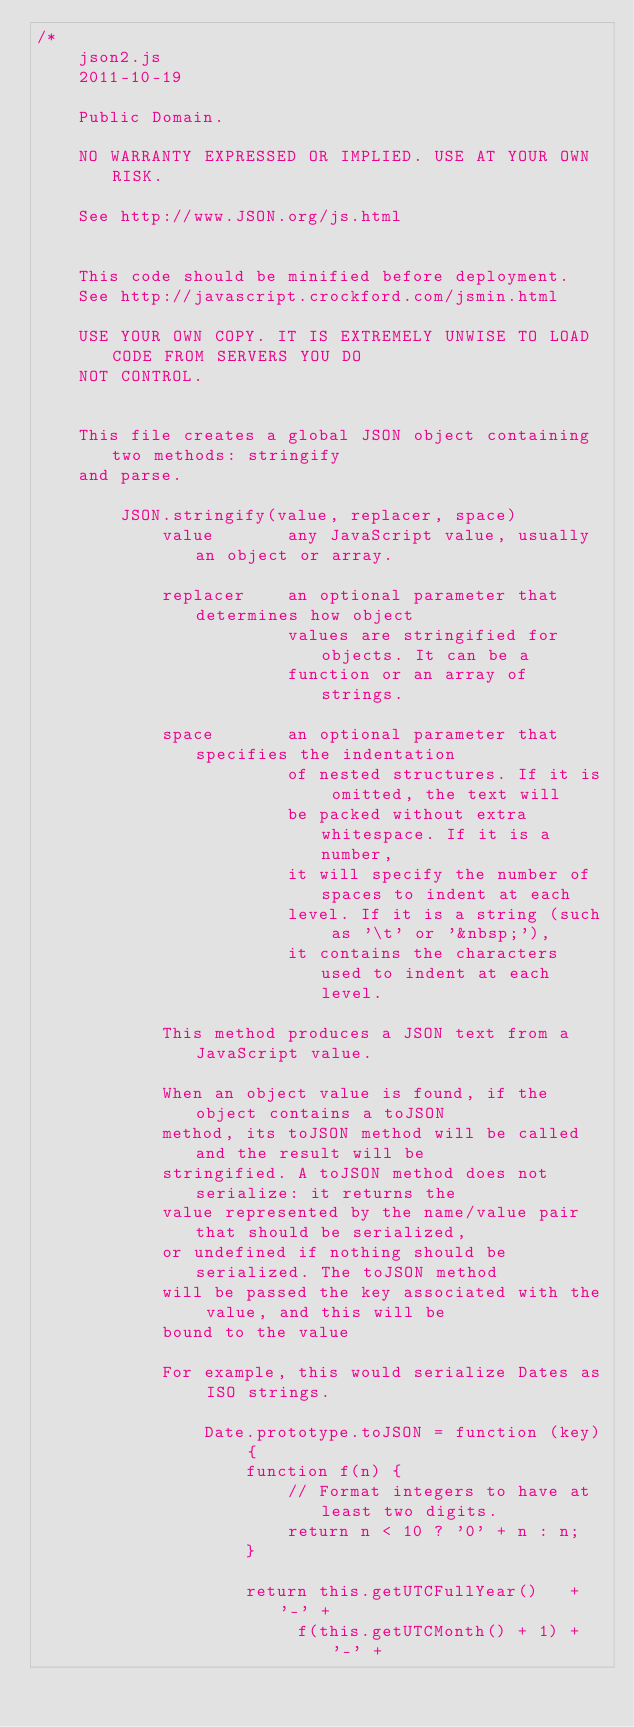Convert code to text. <code><loc_0><loc_0><loc_500><loc_500><_JavaScript_>/*
    json2.js
    2011-10-19

    Public Domain.

    NO WARRANTY EXPRESSED OR IMPLIED. USE AT YOUR OWN RISK.

    See http://www.JSON.org/js.html


    This code should be minified before deployment.
    See http://javascript.crockford.com/jsmin.html

    USE YOUR OWN COPY. IT IS EXTREMELY UNWISE TO LOAD CODE FROM SERVERS YOU DO
    NOT CONTROL.


    This file creates a global JSON object containing two methods: stringify
    and parse.

        JSON.stringify(value, replacer, space)
            value       any JavaScript value, usually an object or array.

            replacer    an optional parameter that determines how object
                        values are stringified for objects. It can be a
                        function or an array of strings.

            space       an optional parameter that specifies the indentation
                        of nested structures. If it is omitted, the text will
                        be packed without extra whitespace. If it is a number,
                        it will specify the number of spaces to indent at each
                        level. If it is a string (such as '\t' or '&nbsp;'),
                        it contains the characters used to indent at each level.

            This method produces a JSON text from a JavaScript value.

            When an object value is found, if the object contains a toJSON
            method, its toJSON method will be called and the result will be
            stringified. A toJSON method does not serialize: it returns the
            value represented by the name/value pair that should be serialized,
            or undefined if nothing should be serialized. The toJSON method
            will be passed the key associated with the value, and this will be
            bound to the value

            For example, this would serialize Dates as ISO strings.

                Date.prototype.toJSON = function (key) {
                    function f(n) {
                        // Format integers to have at least two digits.
                        return n < 10 ? '0' + n : n;
                    }

                    return this.getUTCFullYear()   + '-' +
                         f(this.getUTCMonth() + 1) + '-' +</code> 